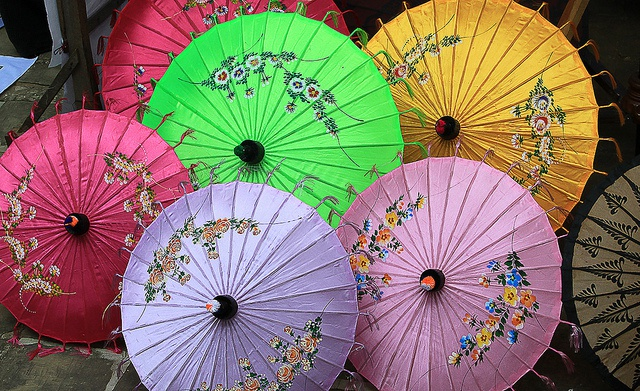Describe the objects in this image and their specific colors. I can see umbrella in black, pink, violet, and brown tones, umbrella in black, lavender, violet, darkgray, and gray tones, umbrella in black, lightgreen, lime, and green tones, umbrella in black, gold, orange, and brown tones, and umbrella in black, violet, maroon, and brown tones in this image. 